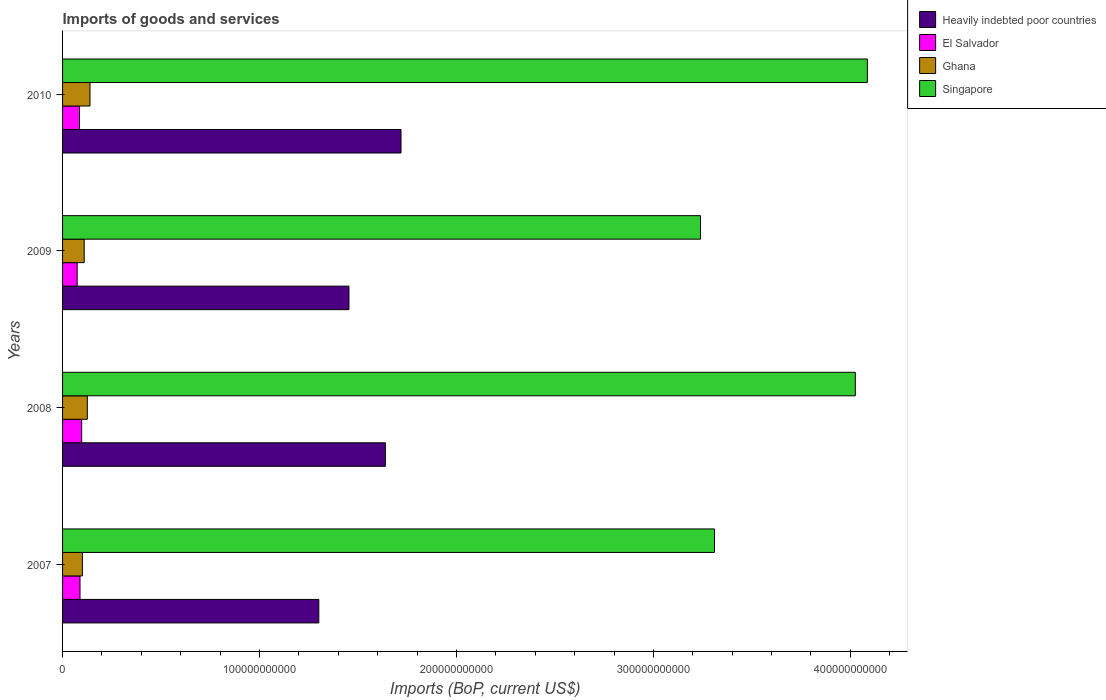How many different coloured bars are there?
Provide a short and direct response. 4. Are the number of bars per tick equal to the number of legend labels?
Give a very brief answer. Yes. How many bars are there on the 4th tick from the bottom?
Your answer should be compact. 4. In how many cases, is the number of bars for a given year not equal to the number of legend labels?
Give a very brief answer. 0. What is the amount spent on imports in Ghana in 2007?
Offer a very short reply. 1.01e+1. Across all years, what is the maximum amount spent on imports in Heavily indebted poor countries?
Your answer should be very brief. 1.72e+11. Across all years, what is the minimum amount spent on imports in Ghana?
Your answer should be very brief. 1.01e+1. What is the total amount spent on imports in Singapore in the graph?
Your answer should be very brief. 1.47e+12. What is the difference between the amount spent on imports in Singapore in 2009 and that in 2010?
Your answer should be very brief. -8.47e+1. What is the difference between the amount spent on imports in Singapore in 2008 and the amount spent on imports in Ghana in 2007?
Give a very brief answer. 3.92e+11. What is the average amount spent on imports in Heavily indebted poor countries per year?
Offer a terse response. 1.53e+11. In the year 2008, what is the difference between the amount spent on imports in Heavily indebted poor countries and amount spent on imports in Ghana?
Provide a succinct answer. 1.51e+11. What is the ratio of the amount spent on imports in Ghana in 2008 to that in 2010?
Make the answer very short. 0.9. Is the difference between the amount spent on imports in Heavily indebted poor countries in 2009 and 2010 greater than the difference between the amount spent on imports in Ghana in 2009 and 2010?
Keep it short and to the point. No. What is the difference between the highest and the second highest amount spent on imports in Ghana?
Ensure brevity in your answer.  1.36e+09. What is the difference between the highest and the lowest amount spent on imports in El Salvador?
Offer a terse response. 2.29e+09. In how many years, is the amount spent on imports in Ghana greater than the average amount spent on imports in Ghana taken over all years?
Give a very brief answer. 2. Is the sum of the amount spent on imports in El Salvador in 2007 and 2009 greater than the maximum amount spent on imports in Singapore across all years?
Make the answer very short. No. What does the 4th bar from the top in 2010 represents?
Give a very brief answer. Heavily indebted poor countries. What does the 3rd bar from the bottom in 2010 represents?
Ensure brevity in your answer.  Ghana. How many years are there in the graph?
Make the answer very short. 4. What is the difference between two consecutive major ticks on the X-axis?
Make the answer very short. 1.00e+11. Does the graph contain grids?
Your answer should be compact. No. Where does the legend appear in the graph?
Offer a very short reply. Top right. How many legend labels are there?
Your response must be concise. 4. How are the legend labels stacked?
Provide a short and direct response. Vertical. What is the title of the graph?
Your response must be concise. Imports of goods and services. Does "Libya" appear as one of the legend labels in the graph?
Offer a very short reply. No. What is the label or title of the X-axis?
Your response must be concise. Imports (BoP, current US$). What is the label or title of the Y-axis?
Your response must be concise. Years. What is the Imports (BoP, current US$) in Heavily indebted poor countries in 2007?
Keep it short and to the point. 1.30e+11. What is the Imports (BoP, current US$) in El Salvador in 2007?
Keep it short and to the point. 8.86e+09. What is the Imports (BoP, current US$) in Ghana in 2007?
Make the answer very short. 1.01e+1. What is the Imports (BoP, current US$) in Singapore in 2007?
Give a very brief answer. 3.31e+11. What is the Imports (BoP, current US$) of Heavily indebted poor countries in 2008?
Keep it short and to the point. 1.64e+11. What is the Imports (BoP, current US$) in El Salvador in 2008?
Offer a terse response. 9.70e+09. What is the Imports (BoP, current US$) in Ghana in 2008?
Keep it short and to the point. 1.26e+1. What is the Imports (BoP, current US$) in Singapore in 2008?
Keep it short and to the point. 4.03e+11. What is the Imports (BoP, current US$) of Heavily indebted poor countries in 2009?
Make the answer very short. 1.45e+11. What is the Imports (BoP, current US$) of El Salvador in 2009?
Provide a short and direct response. 7.41e+09. What is the Imports (BoP, current US$) of Ghana in 2009?
Provide a succinct answer. 1.10e+1. What is the Imports (BoP, current US$) in Singapore in 2009?
Offer a terse response. 3.24e+11. What is the Imports (BoP, current US$) of Heavily indebted poor countries in 2010?
Provide a short and direct response. 1.72e+11. What is the Imports (BoP, current US$) of El Salvador in 2010?
Your answer should be very brief. 8.60e+09. What is the Imports (BoP, current US$) of Ghana in 2010?
Your answer should be very brief. 1.39e+1. What is the Imports (BoP, current US$) in Singapore in 2010?
Provide a short and direct response. 4.09e+11. Across all years, what is the maximum Imports (BoP, current US$) of Heavily indebted poor countries?
Your answer should be very brief. 1.72e+11. Across all years, what is the maximum Imports (BoP, current US$) in El Salvador?
Provide a succinct answer. 9.70e+09. Across all years, what is the maximum Imports (BoP, current US$) of Ghana?
Offer a very short reply. 1.39e+1. Across all years, what is the maximum Imports (BoP, current US$) in Singapore?
Give a very brief answer. 4.09e+11. Across all years, what is the minimum Imports (BoP, current US$) in Heavily indebted poor countries?
Your answer should be compact. 1.30e+11. Across all years, what is the minimum Imports (BoP, current US$) of El Salvador?
Your answer should be compact. 7.41e+09. Across all years, what is the minimum Imports (BoP, current US$) of Ghana?
Your answer should be very brief. 1.01e+1. Across all years, what is the minimum Imports (BoP, current US$) of Singapore?
Offer a terse response. 3.24e+11. What is the total Imports (BoP, current US$) of Heavily indebted poor countries in the graph?
Offer a terse response. 6.11e+11. What is the total Imports (BoP, current US$) in El Salvador in the graph?
Ensure brevity in your answer.  3.46e+1. What is the total Imports (BoP, current US$) of Ghana in the graph?
Give a very brief answer. 4.75e+1. What is the total Imports (BoP, current US$) in Singapore in the graph?
Give a very brief answer. 1.47e+12. What is the difference between the Imports (BoP, current US$) of Heavily indebted poor countries in 2007 and that in 2008?
Provide a succinct answer. -3.38e+1. What is the difference between the Imports (BoP, current US$) in El Salvador in 2007 and that in 2008?
Your response must be concise. -8.44e+08. What is the difference between the Imports (BoP, current US$) of Ghana in 2007 and that in 2008?
Your answer should be very brief. -2.50e+09. What is the difference between the Imports (BoP, current US$) of Singapore in 2007 and that in 2008?
Ensure brevity in your answer.  -7.15e+1. What is the difference between the Imports (BoP, current US$) of Heavily indebted poor countries in 2007 and that in 2009?
Offer a very short reply. -1.53e+1. What is the difference between the Imports (BoP, current US$) in El Salvador in 2007 and that in 2009?
Give a very brief answer. 1.44e+09. What is the difference between the Imports (BoP, current US$) in Ghana in 2007 and that in 2009?
Give a very brief answer. -9.25e+08. What is the difference between the Imports (BoP, current US$) of Singapore in 2007 and that in 2009?
Offer a terse response. 7.10e+09. What is the difference between the Imports (BoP, current US$) of Heavily indebted poor countries in 2007 and that in 2010?
Your answer should be compact. -4.17e+1. What is the difference between the Imports (BoP, current US$) in El Salvador in 2007 and that in 2010?
Your response must be concise. 2.60e+08. What is the difference between the Imports (BoP, current US$) of Ghana in 2007 and that in 2010?
Your answer should be very brief. -3.86e+09. What is the difference between the Imports (BoP, current US$) in Singapore in 2007 and that in 2010?
Make the answer very short. -7.76e+1. What is the difference between the Imports (BoP, current US$) of Heavily indebted poor countries in 2008 and that in 2009?
Provide a succinct answer. 1.85e+1. What is the difference between the Imports (BoP, current US$) in El Salvador in 2008 and that in 2009?
Your answer should be very brief. 2.29e+09. What is the difference between the Imports (BoP, current US$) in Ghana in 2008 and that in 2009?
Offer a terse response. 1.58e+09. What is the difference between the Imports (BoP, current US$) in Singapore in 2008 and that in 2009?
Your response must be concise. 7.86e+1. What is the difference between the Imports (BoP, current US$) in Heavily indebted poor countries in 2008 and that in 2010?
Your answer should be compact. -7.95e+09. What is the difference between the Imports (BoP, current US$) of El Salvador in 2008 and that in 2010?
Provide a succinct answer. 1.10e+09. What is the difference between the Imports (BoP, current US$) of Ghana in 2008 and that in 2010?
Provide a succinct answer. -1.36e+09. What is the difference between the Imports (BoP, current US$) in Singapore in 2008 and that in 2010?
Provide a succinct answer. -6.12e+09. What is the difference between the Imports (BoP, current US$) in Heavily indebted poor countries in 2009 and that in 2010?
Provide a succinct answer. -2.64e+1. What is the difference between the Imports (BoP, current US$) in El Salvador in 2009 and that in 2010?
Offer a very short reply. -1.18e+09. What is the difference between the Imports (BoP, current US$) of Ghana in 2009 and that in 2010?
Offer a terse response. -2.94e+09. What is the difference between the Imports (BoP, current US$) in Singapore in 2009 and that in 2010?
Offer a terse response. -8.47e+1. What is the difference between the Imports (BoP, current US$) in Heavily indebted poor countries in 2007 and the Imports (BoP, current US$) in El Salvador in 2008?
Keep it short and to the point. 1.20e+11. What is the difference between the Imports (BoP, current US$) of Heavily indebted poor countries in 2007 and the Imports (BoP, current US$) of Ghana in 2008?
Your response must be concise. 1.18e+11. What is the difference between the Imports (BoP, current US$) of Heavily indebted poor countries in 2007 and the Imports (BoP, current US$) of Singapore in 2008?
Provide a succinct answer. -2.72e+11. What is the difference between the Imports (BoP, current US$) in El Salvador in 2007 and the Imports (BoP, current US$) in Ghana in 2008?
Keep it short and to the point. -3.71e+09. What is the difference between the Imports (BoP, current US$) in El Salvador in 2007 and the Imports (BoP, current US$) in Singapore in 2008?
Provide a short and direct response. -3.94e+11. What is the difference between the Imports (BoP, current US$) of Ghana in 2007 and the Imports (BoP, current US$) of Singapore in 2008?
Give a very brief answer. -3.92e+11. What is the difference between the Imports (BoP, current US$) of Heavily indebted poor countries in 2007 and the Imports (BoP, current US$) of El Salvador in 2009?
Offer a very short reply. 1.23e+11. What is the difference between the Imports (BoP, current US$) of Heavily indebted poor countries in 2007 and the Imports (BoP, current US$) of Ghana in 2009?
Offer a terse response. 1.19e+11. What is the difference between the Imports (BoP, current US$) of Heavily indebted poor countries in 2007 and the Imports (BoP, current US$) of Singapore in 2009?
Provide a succinct answer. -1.94e+11. What is the difference between the Imports (BoP, current US$) in El Salvador in 2007 and the Imports (BoP, current US$) in Ghana in 2009?
Your answer should be compact. -2.13e+09. What is the difference between the Imports (BoP, current US$) of El Salvador in 2007 and the Imports (BoP, current US$) of Singapore in 2009?
Ensure brevity in your answer.  -3.15e+11. What is the difference between the Imports (BoP, current US$) of Ghana in 2007 and the Imports (BoP, current US$) of Singapore in 2009?
Your answer should be very brief. -3.14e+11. What is the difference between the Imports (BoP, current US$) in Heavily indebted poor countries in 2007 and the Imports (BoP, current US$) in El Salvador in 2010?
Ensure brevity in your answer.  1.22e+11. What is the difference between the Imports (BoP, current US$) of Heavily indebted poor countries in 2007 and the Imports (BoP, current US$) of Ghana in 2010?
Make the answer very short. 1.16e+11. What is the difference between the Imports (BoP, current US$) in Heavily indebted poor countries in 2007 and the Imports (BoP, current US$) in Singapore in 2010?
Your response must be concise. -2.79e+11. What is the difference between the Imports (BoP, current US$) in El Salvador in 2007 and the Imports (BoP, current US$) in Ghana in 2010?
Your response must be concise. -5.07e+09. What is the difference between the Imports (BoP, current US$) in El Salvador in 2007 and the Imports (BoP, current US$) in Singapore in 2010?
Keep it short and to the point. -4.00e+11. What is the difference between the Imports (BoP, current US$) of Ghana in 2007 and the Imports (BoP, current US$) of Singapore in 2010?
Provide a succinct answer. -3.99e+11. What is the difference between the Imports (BoP, current US$) of Heavily indebted poor countries in 2008 and the Imports (BoP, current US$) of El Salvador in 2009?
Offer a very short reply. 1.56e+11. What is the difference between the Imports (BoP, current US$) in Heavily indebted poor countries in 2008 and the Imports (BoP, current US$) in Ghana in 2009?
Keep it short and to the point. 1.53e+11. What is the difference between the Imports (BoP, current US$) in Heavily indebted poor countries in 2008 and the Imports (BoP, current US$) in Singapore in 2009?
Make the answer very short. -1.60e+11. What is the difference between the Imports (BoP, current US$) in El Salvador in 2008 and the Imports (BoP, current US$) in Ghana in 2009?
Offer a very short reply. -1.29e+09. What is the difference between the Imports (BoP, current US$) of El Salvador in 2008 and the Imports (BoP, current US$) of Singapore in 2009?
Provide a succinct answer. -3.14e+11. What is the difference between the Imports (BoP, current US$) of Ghana in 2008 and the Imports (BoP, current US$) of Singapore in 2009?
Make the answer very short. -3.11e+11. What is the difference between the Imports (BoP, current US$) of Heavily indebted poor countries in 2008 and the Imports (BoP, current US$) of El Salvador in 2010?
Give a very brief answer. 1.55e+11. What is the difference between the Imports (BoP, current US$) of Heavily indebted poor countries in 2008 and the Imports (BoP, current US$) of Ghana in 2010?
Offer a very short reply. 1.50e+11. What is the difference between the Imports (BoP, current US$) in Heavily indebted poor countries in 2008 and the Imports (BoP, current US$) in Singapore in 2010?
Your answer should be very brief. -2.45e+11. What is the difference between the Imports (BoP, current US$) in El Salvador in 2008 and the Imports (BoP, current US$) in Ghana in 2010?
Make the answer very short. -4.23e+09. What is the difference between the Imports (BoP, current US$) of El Salvador in 2008 and the Imports (BoP, current US$) of Singapore in 2010?
Offer a terse response. -3.99e+11. What is the difference between the Imports (BoP, current US$) in Ghana in 2008 and the Imports (BoP, current US$) in Singapore in 2010?
Offer a very short reply. -3.96e+11. What is the difference between the Imports (BoP, current US$) in Heavily indebted poor countries in 2009 and the Imports (BoP, current US$) in El Salvador in 2010?
Provide a succinct answer. 1.37e+11. What is the difference between the Imports (BoP, current US$) of Heavily indebted poor countries in 2009 and the Imports (BoP, current US$) of Ghana in 2010?
Your answer should be very brief. 1.31e+11. What is the difference between the Imports (BoP, current US$) in Heavily indebted poor countries in 2009 and the Imports (BoP, current US$) in Singapore in 2010?
Your answer should be compact. -2.63e+11. What is the difference between the Imports (BoP, current US$) of El Salvador in 2009 and the Imports (BoP, current US$) of Ghana in 2010?
Ensure brevity in your answer.  -6.51e+09. What is the difference between the Imports (BoP, current US$) in El Salvador in 2009 and the Imports (BoP, current US$) in Singapore in 2010?
Provide a succinct answer. -4.01e+11. What is the difference between the Imports (BoP, current US$) in Ghana in 2009 and the Imports (BoP, current US$) in Singapore in 2010?
Provide a succinct answer. -3.98e+11. What is the average Imports (BoP, current US$) of Heavily indebted poor countries per year?
Your answer should be very brief. 1.53e+11. What is the average Imports (BoP, current US$) of El Salvador per year?
Provide a short and direct response. 8.64e+09. What is the average Imports (BoP, current US$) in Ghana per year?
Provide a succinct answer. 1.19e+1. What is the average Imports (BoP, current US$) in Singapore per year?
Ensure brevity in your answer.  3.67e+11. In the year 2007, what is the difference between the Imports (BoP, current US$) in Heavily indebted poor countries and Imports (BoP, current US$) in El Salvador?
Your response must be concise. 1.21e+11. In the year 2007, what is the difference between the Imports (BoP, current US$) of Heavily indebted poor countries and Imports (BoP, current US$) of Ghana?
Provide a succinct answer. 1.20e+11. In the year 2007, what is the difference between the Imports (BoP, current US$) of Heavily indebted poor countries and Imports (BoP, current US$) of Singapore?
Your response must be concise. -2.01e+11. In the year 2007, what is the difference between the Imports (BoP, current US$) in El Salvador and Imports (BoP, current US$) in Ghana?
Offer a terse response. -1.21e+09. In the year 2007, what is the difference between the Imports (BoP, current US$) of El Salvador and Imports (BoP, current US$) of Singapore?
Your answer should be very brief. -3.22e+11. In the year 2007, what is the difference between the Imports (BoP, current US$) of Ghana and Imports (BoP, current US$) of Singapore?
Your answer should be compact. -3.21e+11. In the year 2008, what is the difference between the Imports (BoP, current US$) in Heavily indebted poor countries and Imports (BoP, current US$) in El Salvador?
Give a very brief answer. 1.54e+11. In the year 2008, what is the difference between the Imports (BoP, current US$) in Heavily indebted poor countries and Imports (BoP, current US$) in Ghana?
Give a very brief answer. 1.51e+11. In the year 2008, what is the difference between the Imports (BoP, current US$) in Heavily indebted poor countries and Imports (BoP, current US$) in Singapore?
Make the answer very short. -2.39e+11. In the year 2008, what is the difference between the Imports (BoP, current US$) in El Salvador and Imports (BoP, current US$) in Ghana?
Ensure brevity in your answer.  -2.87e+09. In the year 2008, what is the difference between the Imports (BoP, current US$) in El Salvador and Imports (BoP, current US$) in Singapore?
Make the answer very short. -3.93e+11. In the year 2008, what is the difference between the Imports (BoP, current US$) of Ghana and Imports (BoP, current US$) of Singapore?
Offer a very short reply. -3.90e+11. In the year 2009, what is the difference between the Imports (BoP, current US$) of Heavily indebted poor countries and Imports (BoP, current US$) of El Salvador?
Make the answer very short. 1.38e+11. In the year 2009, what is the difference between the Imports (BoP, current US$) of Heavily indebted poor countries and Imports (BoP, current US$) of Ghana?
Your answer should be very brief. 1.34e+11. In the year 2009, what is the difference between the Imports (BoP, current US$) in Heavily indebted poor countries and Imports (BoP, current US$) in Singapore?
Provide a short and direct response. -1.79e+11. In the year 2009, what is the difference between the Imports (BoP, current US$) in El Salvador and Imports (BoP, current US$) in Ghana?
Your answer should be compact. -3.58e+09. In the year 2009, what is the difference between the Imports (BoP, current US$) in El Salvador and Imports (BoP, current US$) in Singapore?
Provide a succinct answer. -3.17e+11. In the year 2009, what is the difference between the Imports (BoP, current US$) of Ghana and Imports (BoP, current US$) of Singapore?
Keep it short and to the point. -3.13e+11. In the year 2010, what is the difference between the Imports (BoP, current US$) in Heavily indebted poor countries and Imports (BoP, current US$) in El Salvador?
Make the answer very short. 1.63e+11. In the year 2010, what is the difference between the Imports (BoP, current US$) in Heavily indebted poor countries and Imports (BoP, current US$) in Ghana?
Your answer should be very brief. 1.58e+11. In the year 2010, what is the difference between the Imports (BoP, current US$) in Heavily indebted poor countries and Imports (BoP, current US$) in Singapore?
Your answer should be compact. -2.37e+11. In the year 2010, what is the difference between the Imports (BoP, current US$) of El Salvador and Imports (BoP, current US$) of Ghana?
Ensure brevity in your answer.  -5.33e+09. In the year 2010, what is the difference between the Imports (BoP, current US$) in El Salvador and Imports (BoP, current US$) in Singapore?
Ensure brevity in your answer.  -4.00e+11. In the year 2010, what is the difference between the Imports (BoP, current US$) of Ghana and Imports (BoP, current US$) of Singapore?
Your answer should be very brief. -3.95e+11. What is the ratio of the Imports (BoP, current US$) of Heavily indebted poor countries in 2007 to that in 2008?
Make the answer very short. 0.79. What is the ratio of the Imports (BoP, current US$) of El Salvador in 2007 to that in 2008?
Provide a succinct answer. 0.91. What is the ratio of the Imports (BoP, current US$) in Ghana in 2007 to that in 2008?
Your response must be concise. 0.8. What is the ratio of the Imports (BoP, current US$) of Singapore in 2007 to that in 2008?
Your answer should be very brief. 0.82. What is the ratio of the Imports (BoP, current US$) in Heavily indebted poor countries in 2007 to that in 2009?
Your response must be concise. 0.89. What is the ratio of the Imports (BoP, current US$) in El Salvador in 2007 to that in 2009?
Keep it short and to the point. 1.19. What is the ratio of the Imports (BoP, current US$) of Ghana in 2007 to that in 2009?
Make the answer very short. 0.92. What is the ratio of the Imports (BoP, current US$) of Singapore in 2007 to that in 2009?
Your answer should be very brief. 1.02. What is the ratio of the Imports (BoP, current US$) in Heavily indebted poor countries in 2007 to that in 2010?
Offer a terse response. 0.76. What is the ratio of the Imports (BoP, current US$) in El Salvador in 2007 to that in 2010?
Your answer should be compact. 1.03. What is the ratio of the Imports (BoP, current US$) of Ghana in 2007 to that in 2010?
Your answer should be compact. 0.72. What is the ratio of the Imports (BoP, current US$) of Singapore in 2007 to that in 2010?
Provide a succinct answer. 0.81. What is the ratio of the Imports (BoP, current US$) in Heavily indebted poor countries in 2008 to that in 2009?
Provide a short and direct response. 1.13. What is the ratio of the Imports (BoP, current US$) of El Salvador in 2008 to that in 2009?
Keep it short and to the point. 1.31. What is the ratio of the Imports (BoP, current US$) of Ghana in 2008 to that in 2009?
Provide a succinct answer. 1.14. What is the ratio of the Imports (BoP, current US$) in Singapore in 2008 to that in 2009?
Your answer should be very brief. 1.24. What is the ratio of the Imports (BoP, current US$) of Heavily indebted poor countries in 2008 to that in 2010?
Keep it short and to the point. 0.95. What is the ratio of the Imports (BoP, current US$) in El Salvador in 2008 to that in 2010?
Ensure brevity in your answer.  1.13. What is the ratio of the Imports (BoP, current US$) in Ghana in 2008 to that in 2010?
Your answer should be very brief. 0.9. What is the ratio of the Imports (BoP, current US$) of Heavily indebted poor countries in 2009 to that in 2010?
Make the answer very short. 0.85. What is the ratio of the Imports (BoP, current US$) in El Salvador in 2009 to that in 2010?
Make the answer very short. 0.86. What is the ratio of the Imports (BoP, current US$) of Ghana in 2009 to that in 2010?
Provide a succinct answer. 0.79. What is the ratio of the Imports (BoP, current US$) of Singapore in 2009 to that in 2010?
Provide a succinct answer. 0.79. What is the difference between the highest and the second highest Imports (BoP, current US$) of Heavily indebted poor countries?
Provide a succinct answer. 7.95e+09. What is the difference between the highest and the second highest Imports (BoP, current US$) of El Salvador?
Give a very brief answer. 8.44e+08. What is the difference between the highest and the second highest Imports (BoP, current US$) of Ghana?
Keep it short and to the point. 1.36e+09. What is the difference between the highest and the second highest Imports (BoP, current US$) of Singapore?
Give a very brief answer. 6.12e+09. What is the difference between the highest and the lowest Imports (BoP, current US$) in Heavily indebted poor countries?
Your answer should be compact. 4.17e+1. What is the difference between the highest and the lowest Imports (BoP, current US$) in El Salvador?
Provide a succinct answer. 2.29e+09. What is the difference between the highest and the lowest Imports (BoP, current US$) in Ghana?
Your response must be concise. 3.86e+09. What is the difference between the highest and the lowest Imports (BoP, current US$) in Singapore?
Ensure brevity in your answer.  8.47e+1. 